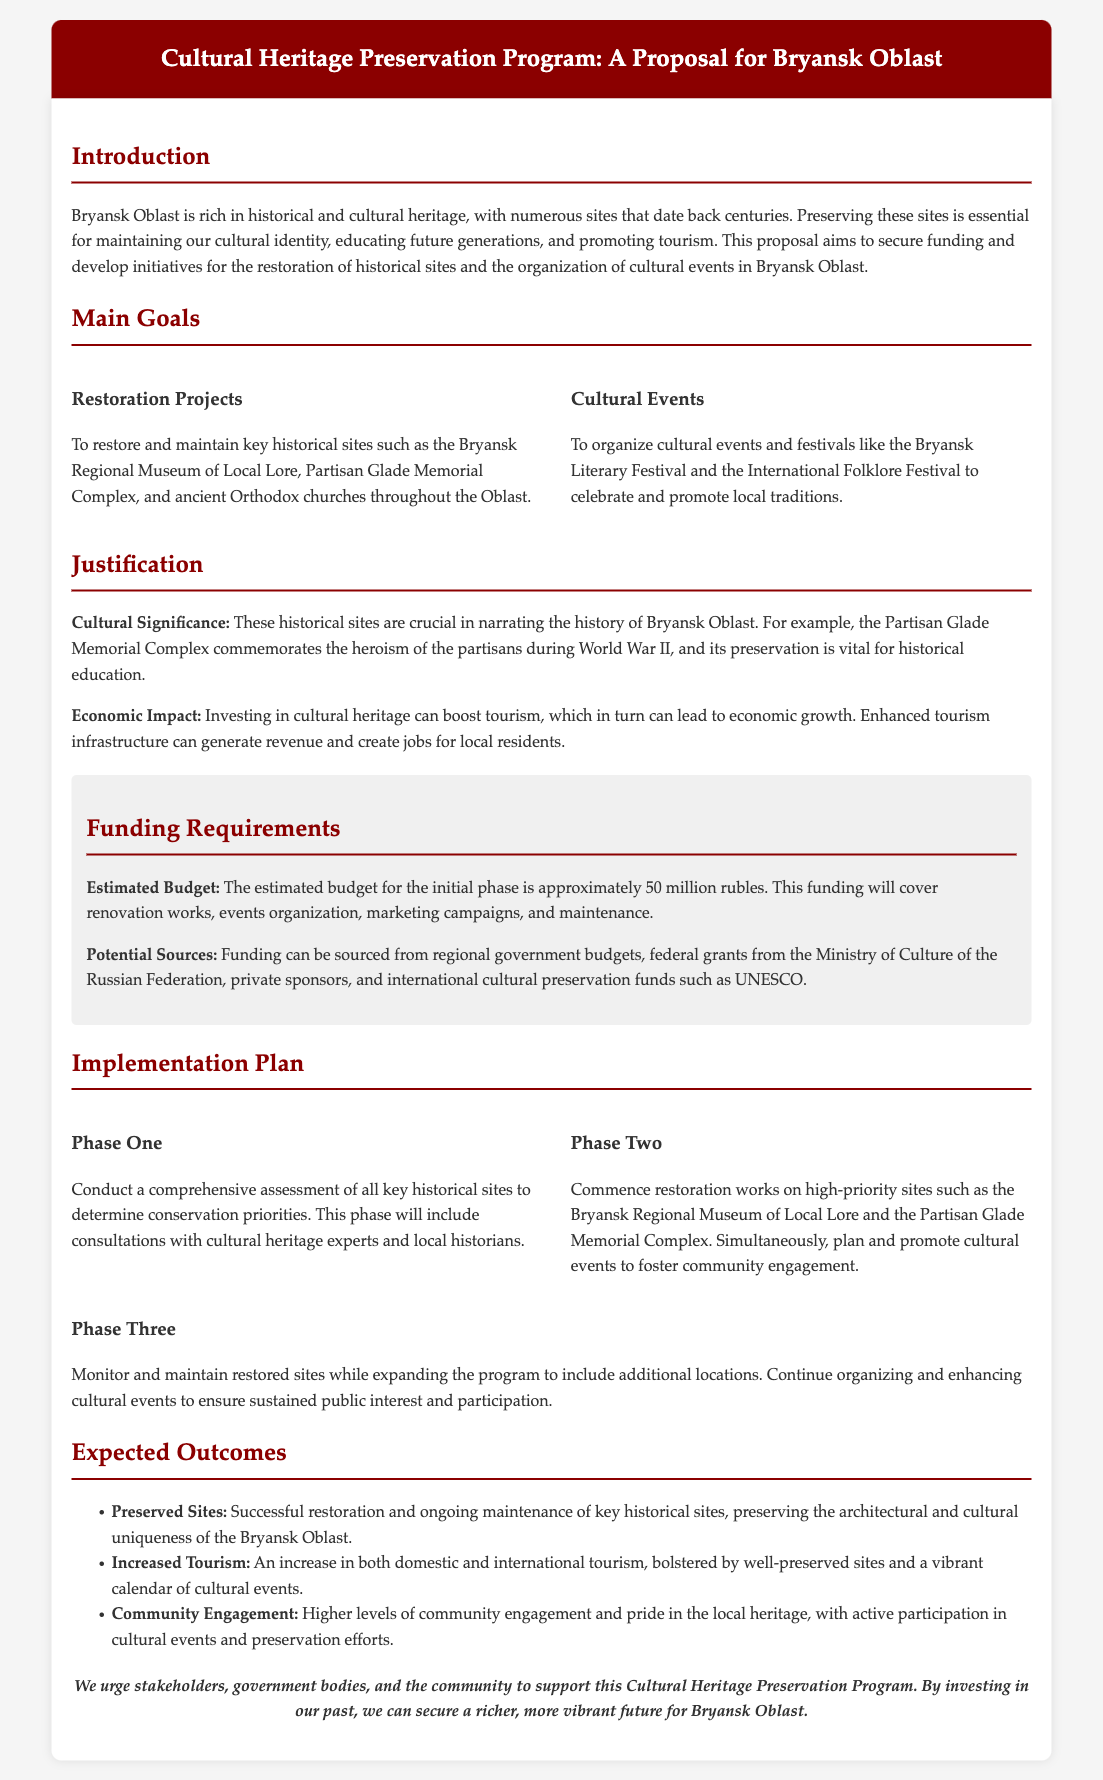What is the estimated budget for the initial phase? The estimated budget mentioned in the document is for the restoration projects and the organization of cultural events.
Answer: 50 million rubles What are the key historical sites mentioned for restoration? The document lists specific sites scheduled for restoration, highlighting their significance.
Answer: Bryansk Regional Museum of Local Lore, Partisan Glade Memorial Complex, ancient Orthodox churches What is one of the cultural events proposed in the program? The proposal outlines cultural events aimed at promoting local traditions.
Answer: Bryansk Literary Festival What is the main goal of the Cultural Heritage Preservation Program? The primary goal is to secure funding for restoring historical sites and organizing cultural events, thus emphasizing cultural identity.
Answer: Restoration of historical sites and organization of cultural events In which phase will assessments of cultural sites occur? The proposal details phases of implementation, making it clear at which stage specific activities will take place.
Answer: Phase One What is a potential source of funding mentioned in the proposal? The document identifies various sources for funding the program to ensure financial support for the proposed activities.
Answer: Government budgets How does the proposal aim to boost local tourism? The document explains how enhancing historical site preservation is linked to tourism benefits, requiring an understanding of economic impact.
Answer: By restoring sites and organizing cultural events What is indicated as a crucial aspect of the proposed program's significance? The document emphasizes the educational and cultural importance of preserving historical sites for future generations.
Answer: Cultural significance What is proposed in Phase Three of the implementation plan? The plan outlines specific activities in Phase Three, demonstrating continuity and future expansion of the program.
Answer: Monitor and maintain restored sites 